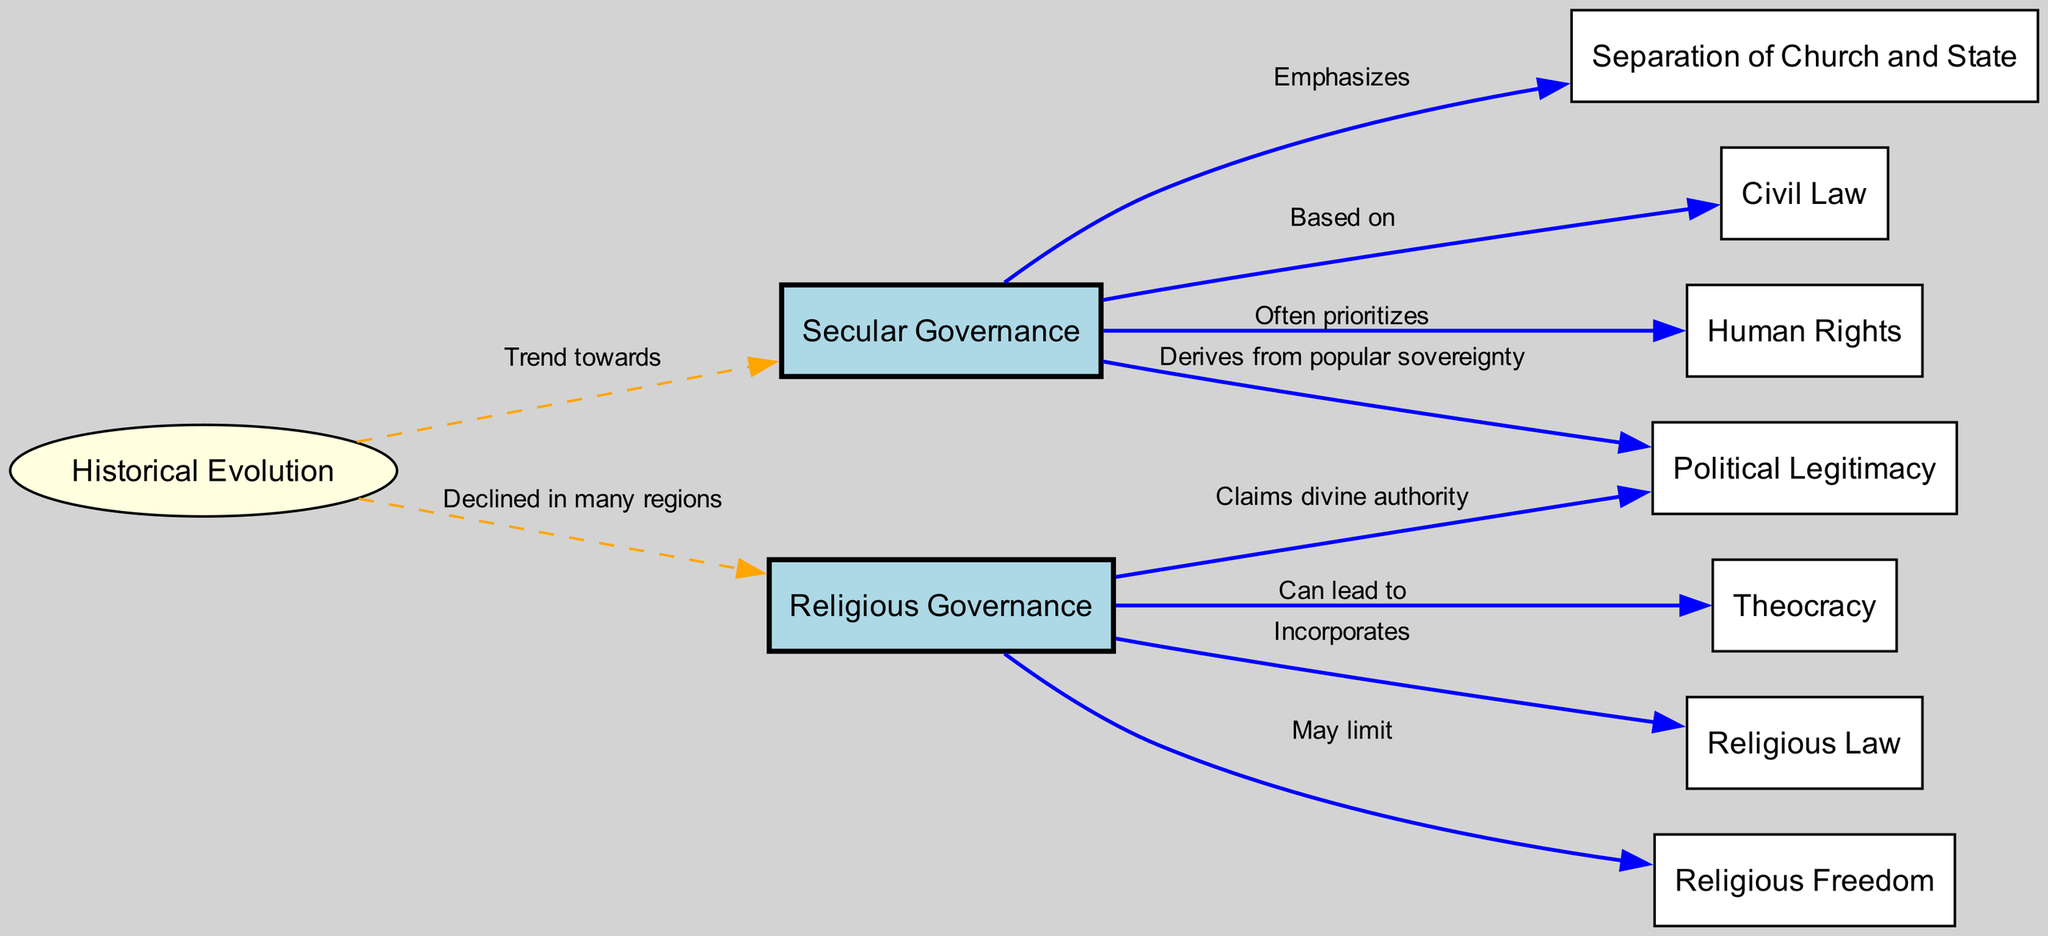What is the primary feature of secular governance? The diagram indicates that secular governance emphasizes the separation of church and state. This is directly depicted by the edge connecting "Secular Governance" and "Separation of Church and State," labeled "Emphasizes."
Answer: Separation of Church and State Which type of governance can lead to theocracy? The diagram shows that religious governance can lead to theocracy as indicated by the edge from "Religious Governance" to "Theocracy," labeled "Can lead to."
Answer: Theocracy What type of law is secular governance based on? According to the diagram, secular governance is based on civil law, which is illustrated by the connection between "Secular Governance" and "Civil Law," marked with the label "Based on."
Answer: Civil Law What is a potential limitation of religious governance? The diagram specifies that religious governance may limit religious freedom, as shown by the edge from "Religious Governance" to "Religious Freedom," labeled "May limit."
Answer: Religious Freedom How does secular governance derive its political legitimacy? The diagram explains that secular governance derives its political legitimacy from popular sovereignty, which is indicated by the edge connecting "Secular Governance" and "Political Legitimacy," labeled "Derives from popular sovereignty."
Answer: Popular sovereignty What does historical evolution indicate about secular governance? The relationship depicted in the diagram between "Historical Evolution" and "Secular Governance" suggests that there is a trend towards secular governance, marked by the edge labeled "Trend towards."
Answer: Trend towards What is the relationship between historical evolution and religious governance? The diagram indicates that historical evolution shows a decline of religious governance in many regions, represented by the edge from "Historical Evolution" to "Religious Governance," labeled "Declined in many regions."
Answer: Declined in many regions How many nodes are represented in the diagram? By counting the nodes listed in the data, we find that there are a total of 10 nodes in the diagram, which include all the concepts related to secular and religious governance.
Answer: 10 What is the nature of the edge between secular governance and political legitimacy? The diagram indicates that the connection between "Secular Governance" and "Political Legitimacy" is solid, labeled as "Derives from popular sovereignty," showing a direct and strong relationship.
Answer: Solid connection Which law system is incorporated in religious governance? The diagram illustrates that religious governance incorporates religious law, as evidenced by the edge from "Religious Governance" to "Religious Law," labeled "Incorporates."
Answer: Religious Law 